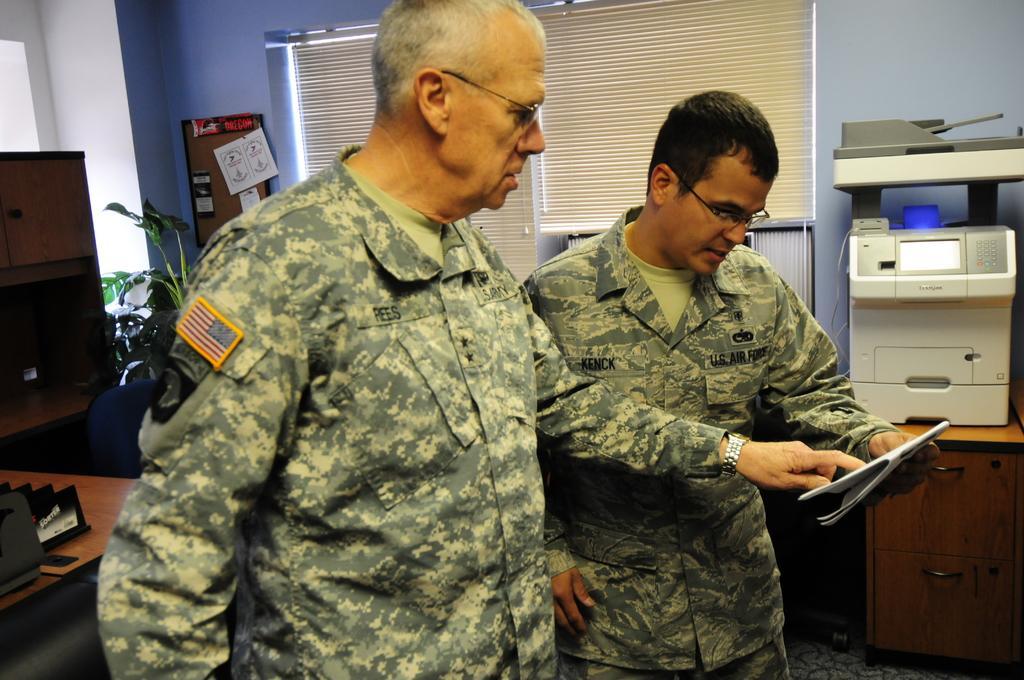Describe this image in one or two sentences. In this image there are two army officers who are looking into the book. In the background there are curtains. On the left side there is a table on which there are books and a chair beside it. On the right side there is a printer on the table. On the left side there is a cupboard. Beside the cupboard there is a plant. 